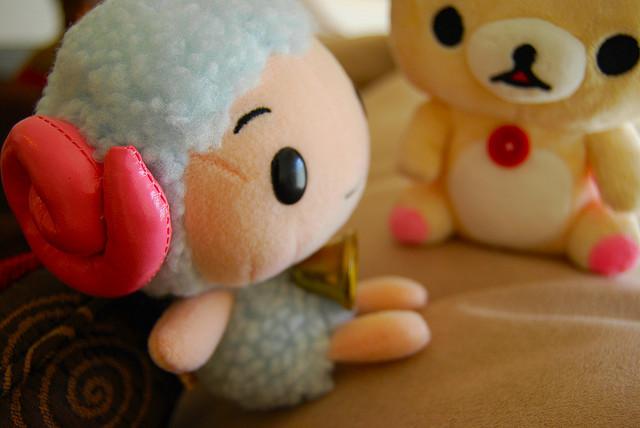What shape is one the right bear in the front?
Short answer required. Round. What are these doll's made of?
Keep it brief. Cloth. Who do these items probably belong to?
Write a very short answer. Child. How many dolls are there?
Short answer required. 2. What do you see on the oranges that might bring a smile to a human's face?
Give a very brief answer. Nose. 